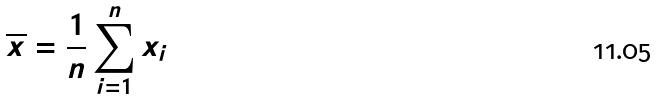<formula> <loc_0><loc_0><loc_500><loc_500>\overline { x } = \frac { 1 } { n } \sum _ { i = 1 } ^ { n } x _ { i }</formula> 